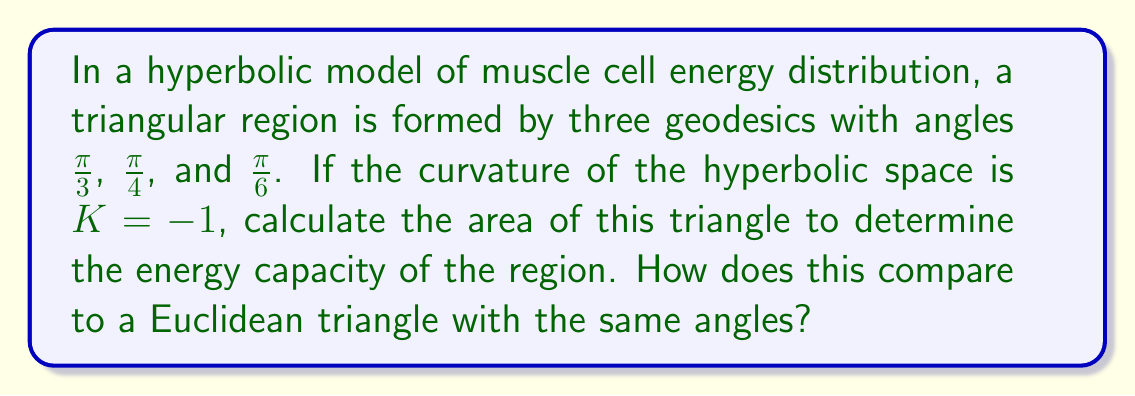Solve this math problem. To solve this problem, we'll use the Gauss-Bonnet formula for hyperbolic triangles and compare it to the Euclidean case:

1. Recall the Gauss-Bonnet formula for a hyperbolic triangle:
   $$A = -K(\alpha + \beta + \gamma - \pi)$$
   where $A$ is the area, $K$ is the curvature, and $\alpha$, $\beta$, $\gamma$ are the angles of the triangle.

2. Given angles: $\alpha = \frac{\pi}{3}$, $\beta = \frac{\pi}{4}$, $\gamma = \frac{\pi}{6}$
   Curvature: $K = -1$

3. Sum the angles:
   $$\alpha + \beta + \gamma = \frac{\pi}{3} + \frac{\pi}{4} + \frac{\pi}{6} = \frac{4\pi}{12} + \frac{3\pi}{12} + \frac{2\pi}{12} = \frac{9\pi}{12} = \frac{3\pi}{4}$$

4. Apply the Gauss-Bonnet formula:
   $$A = -(-1)(\frac{3\pi}{4} - \pi) = \frac{\pi}{4}$$

5. For comparison, in Euclidean geometry, a triangle with these angles is impossible as the sum of angles would exceed $\pi$. The closest Euclidean analogue would have area 0.

This larger area in hyperbolic space indicates a higher energy capacity in the muscle cell model compared to a Euclidean approximation.
Answer: $\frac{\pi}{4}$ square units 